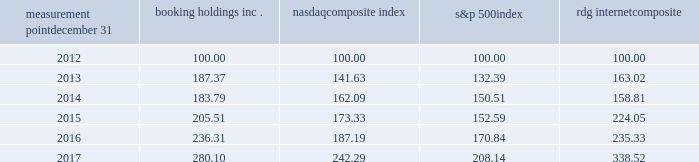Measurement point december 31 booking holdings nasdaq composite index s&p 500 rdg internet composite .
Sales of unregistered securities between october 1 , 2017 and december 31 , 2017 , we issued 103343 shares of our common stock in connection with the conversion of $ 196.1 million principal amount of our 1.0% ( 1.0 % ) convertible senior notes due 2018 .
The conversions were effected in accordance with the indenture , which provides that the principal amount of converted notes be paid in cash and the conversion premium be paid in cash and/or shares of common stock at our election .
In each case , we chose to pay the conversion premium in shares of common stock ( fractional shares are paid in cash ) .
The issuances of the shares were not registered under the securities act of 1933 , as amended ( the "act" ) pursuant to section 3 ( a ) ( 9 ) of the act. .
What was the percent of the growth in meausurement of the booking holdings inc.2016 to 2017? 
Rationale: the growth in measurement of the booking holdings inc.2016 to 2017 was 18.5%
Computations: (280.10 - 236.31)
Answer: 43.79. Measurement point december 31 booking holdings nasdaq composite index s&p 500 rdg internet composite .
Sales of unregistered securities between october 1 , 2017 and december 31 , 2017 , we issued 103343 shares of our common stock in connection with the conversion of $ 196.1 million principal amount of our 1.0% ( 1.0 % ) convertible senior notes due 2018 .
The conversions were effected in accordance with the indenture , which provides that the principal amount of converted notes be paid in cash and the conversion premium be paid in cash and/or shares of common stock at our election .
In each case , we chose to pay the conversion premium in shares of common stock ( fractional shares are paid in cash ) .
The issuances of the shares were not registered under the securities act of 1933 , as amended ( the "act" ) pursuant to section 3 ( a ) ( 9 ) of the act. .
At the measurement point december 312016 what was the ratio of the booking holdings inc . to the nasdaqcomposite index? 
Rationale: at the measurement point december 312016 the ratio of the booking holdings inc . to the nasdaqcomposite index was 1.26 to 1
Computations: (236.31 / 187.19)
Answer: 1.26241. Measurement point december 31 booking holdings nasdaq composite index s&p 500 rdg internet composite .
Sales of unregistered securities between october 1 , 2017 and december 31 , 2017 , we issued 103343 shares of our common stock in connection with the conversion of $ 196.1 million principal amount of our 1.0% ( 1.0 % ) convertible senior notes due 2018 .
The conversions were effected in accordance with the indenture , which provides that the principal amount of converted notes be paid in cash and the conversion premium be paid in cash and/or shares of common stock at our election .
In each case , we chose to pay the conversion premium in shares of common stock ( fractional shares are paid in cash ) .
The issuances of the shares were not registered under the securities act of 1933 , as amended ( the "act" ) pursuant to section 3 ( a ) ( 9 ) of the act. .
What was the percentage change in booking holdings inc . for the five years ended 2017? 
Computations: ((280.10 - 100) / 100)
Answer: 1.801. 